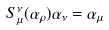<formula> <loc_0><loc_0><loc_500><loc_500>S _ { \mu } ^ { \nu } ( \alpha _ { \rho } ) \alpha _ { \nu } = \alpha _ { \mu }</formula> 